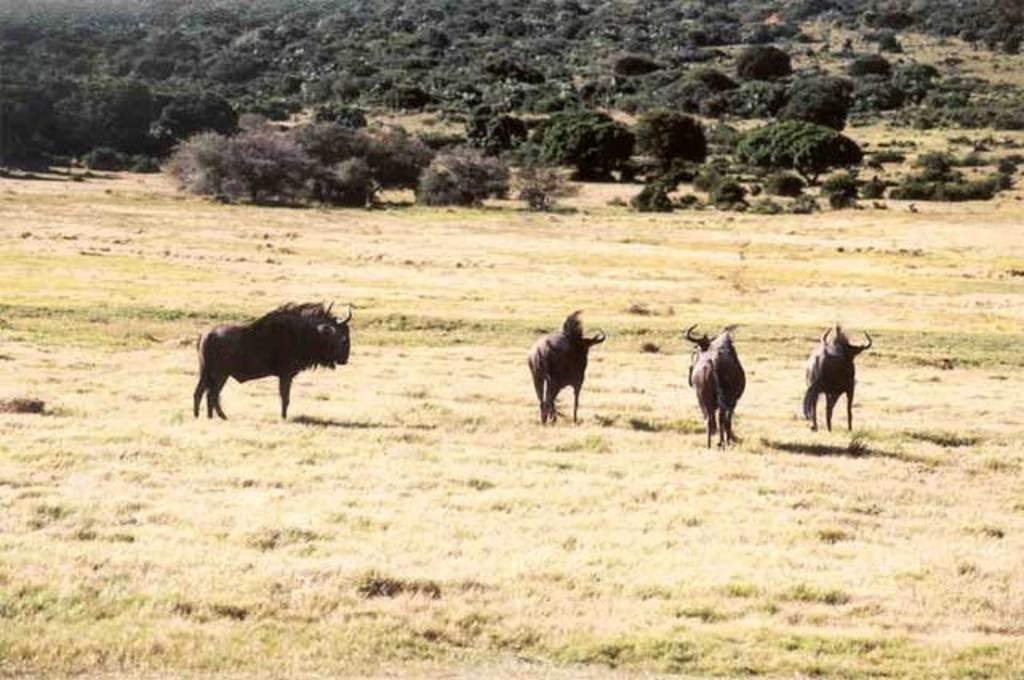How would you summarize this image in a sentence or two? In this image we can see the animals and also the grass. We can also see the trees and plants. 